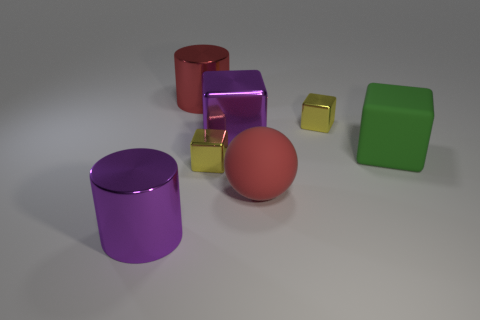Add 1 big blue metallic things. How many objects exist? 8 Subtract all balls. How many objects are left? 6 Subtract 0 blue balls. How many objects are left? 7 Subtract all metal objects. Subtract all large cyan matte cylinders. How many objects are left? 2 Add 5 rubber cubes. How many rubber cubes are left? 6 Add 3 brown rubber objects. How many brown rubber objects exist? 3 